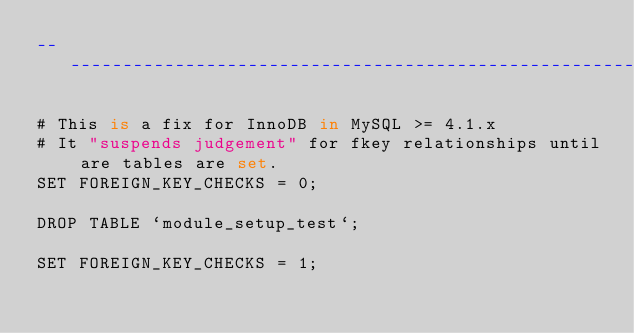Convert code to text. <code><loc_0><loc_0><loc_500><loc_500><_SQL_>-- ---------------------------------------------------------------------

# This is a fix for InnoDB in MySQL >= 4.1.x
# It "suspends judgement" for fkey relationships until are tables are set.
SET FOREIGN_KEY_CHECKS = 0;

DROP TABLE `module_setup_test`;

SET FOREIGN_KEY_CHECKS = 1;</code> 